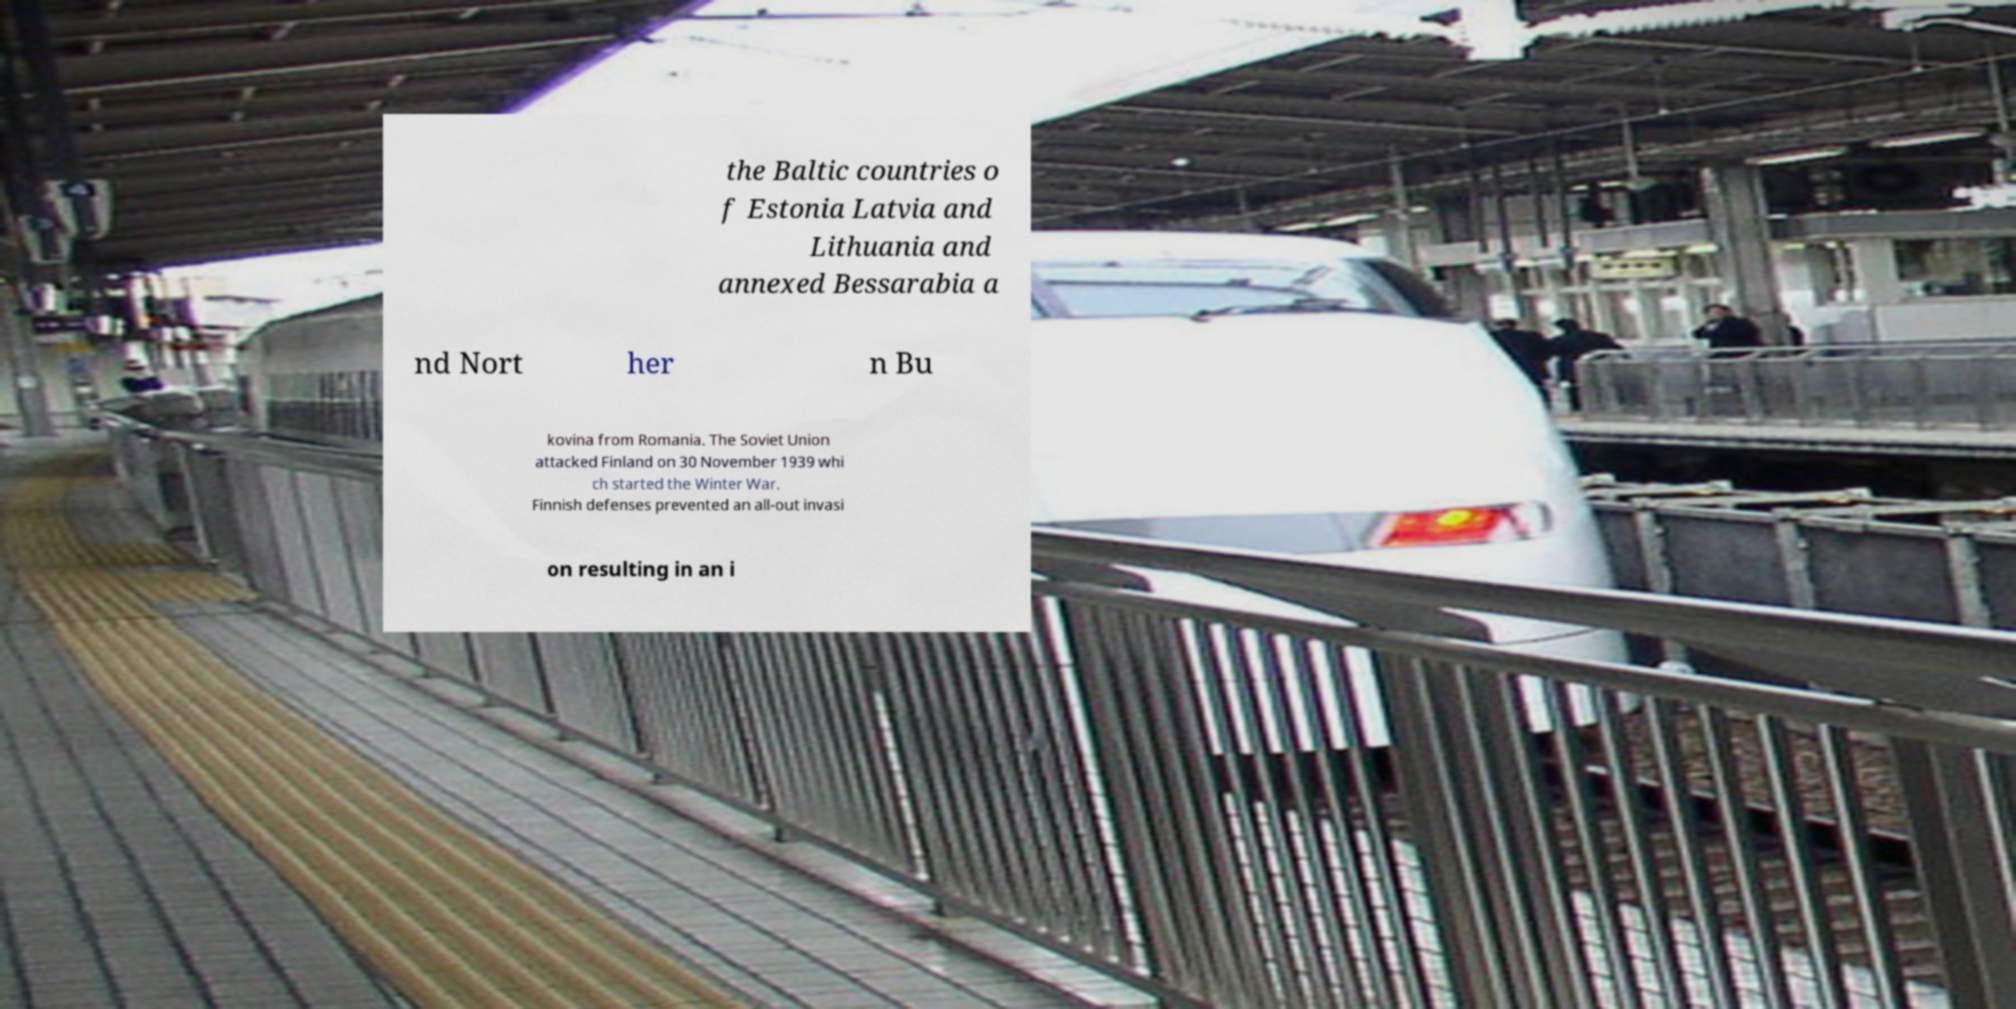Please identify and transcribe the text found in this image. the Baltic countries o f Estonia Latvia and Lithuania and annexed Bessarabia a nd Nort her n Bu kovina from Romania. The Soviet Union attacked Finland on 30 November 1939 whi ch started the Winter War. Finnish defenses prevented an all-out invasi on resulting in an i 